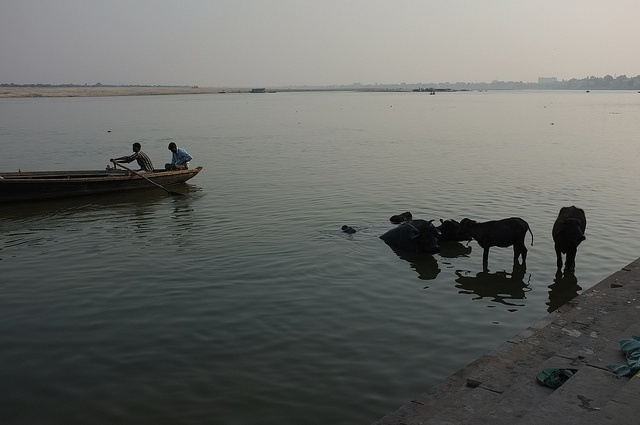Describe the objects in this image and their specific colors. I can see boat in gray and black tones, cow in gray and black tones, cow in gray and black tones, cow in black and gray tones, and people in gray, black, darkgray, and darkblue tones in this image. 